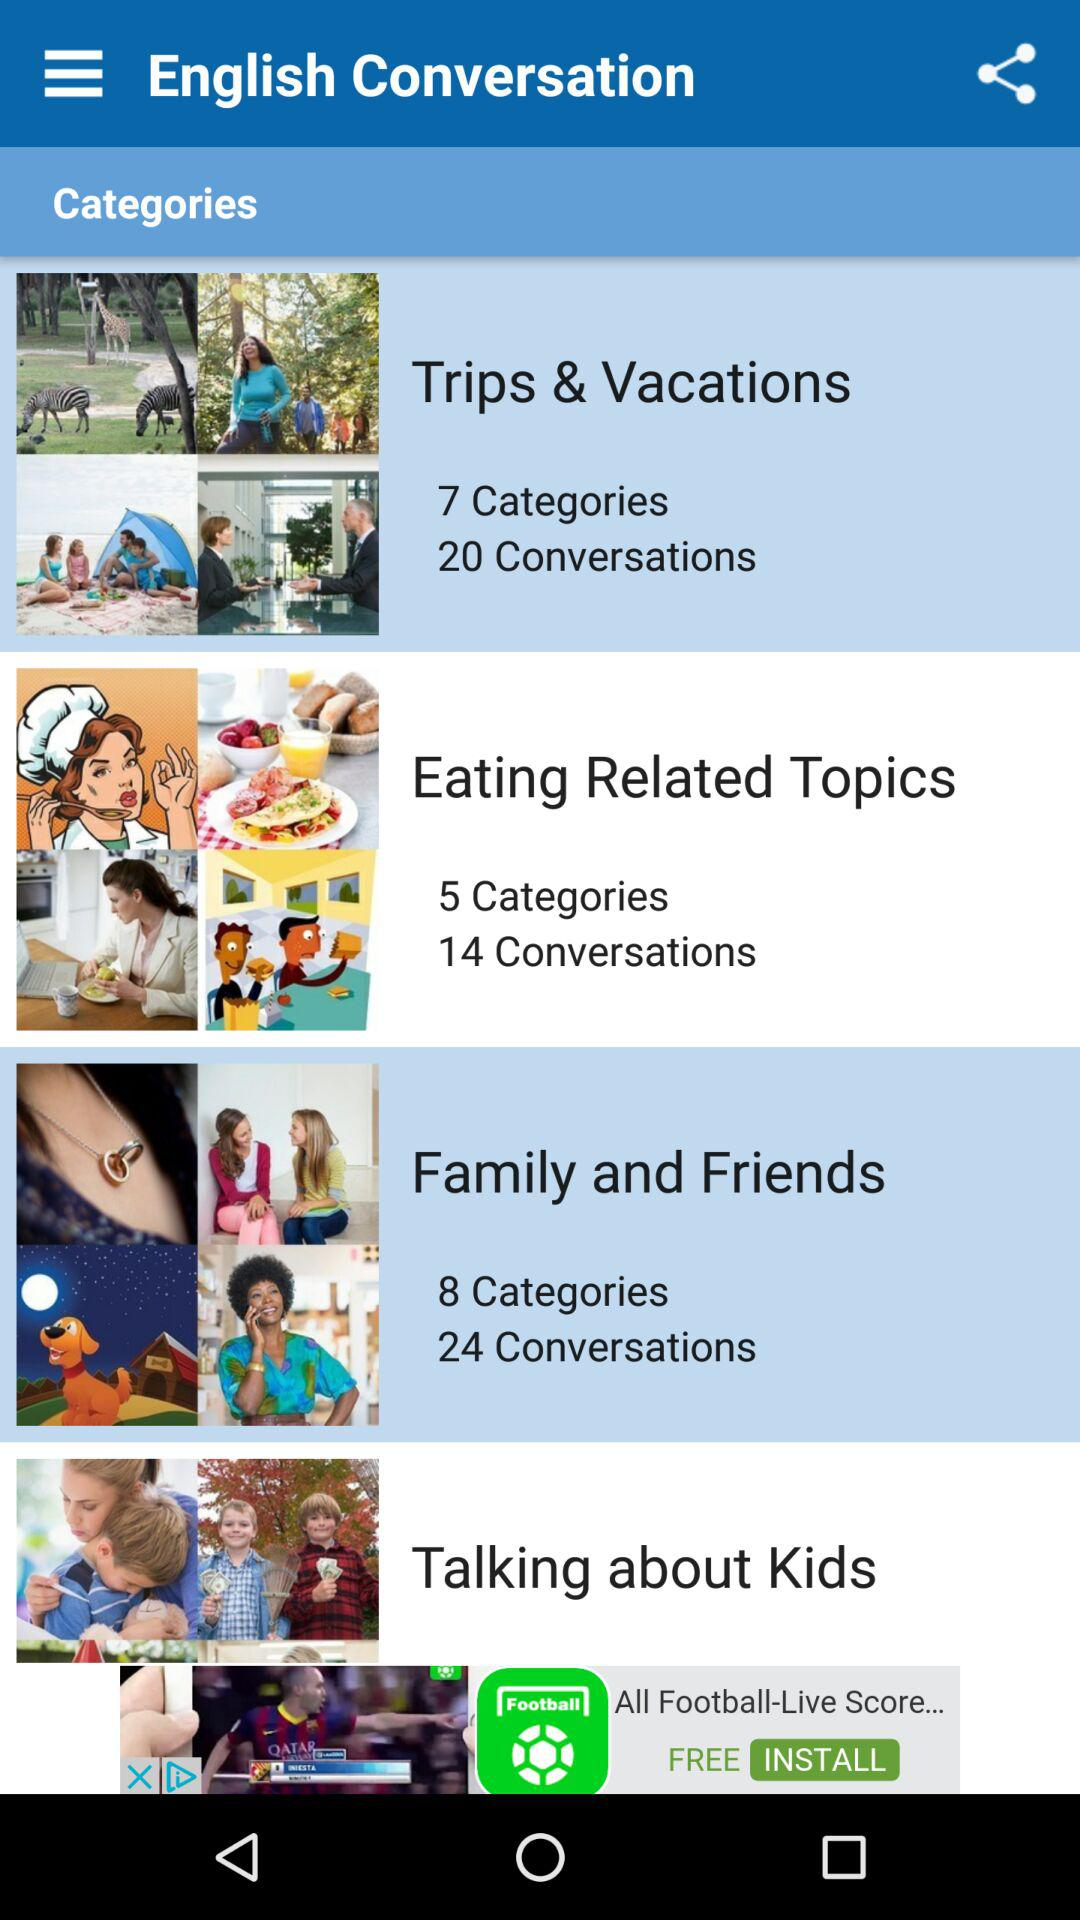How many more conversations are there in the Family and Friends category than the Eating Related Topics category?
Answer the question using a single word or phrase. 10 